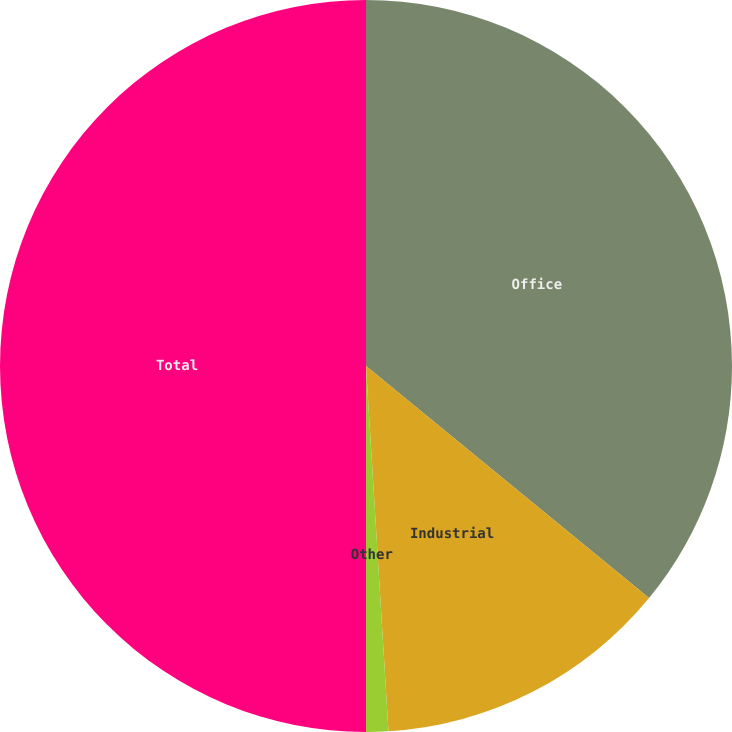<chart> <loc_0><loc_0><loc_500><loc_500><pie_chart><fcel>Office<fcel>Industrial<fcel>Other<fcel>Total<nl><fcel>35.93%<fcel>13.09%<fcel>0.98%<fcel>50.0%<nl></chart> 